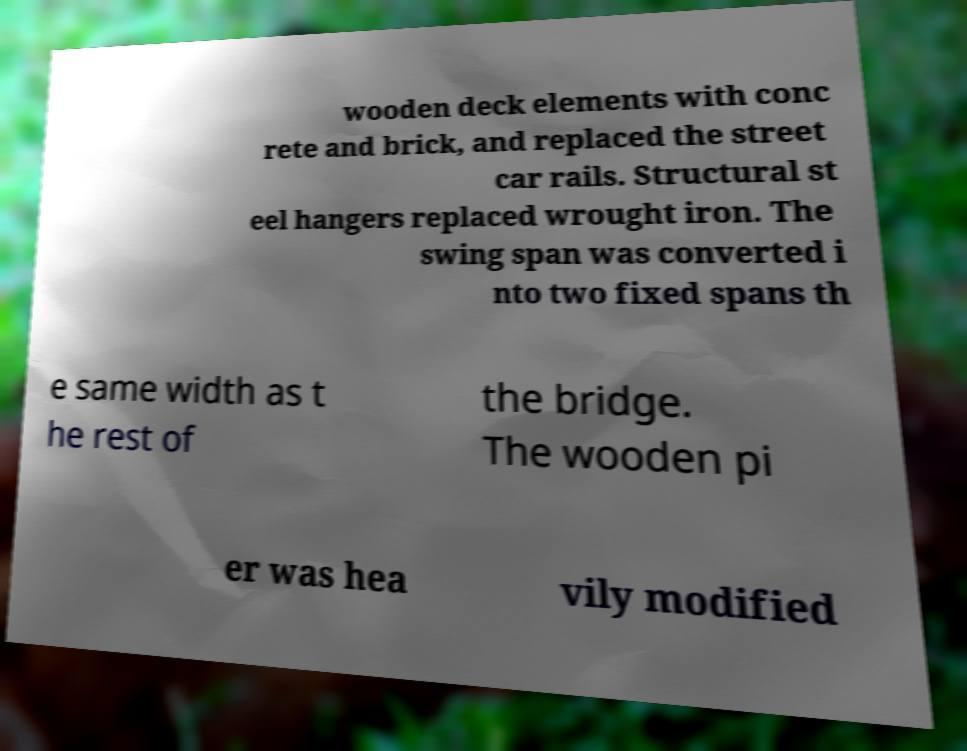There's text embedded in this image that I need extracted. Can you transcribe it verbatim? wooden deck elements with conc rete and brick, and replaced the street car rails. Structural st eel hangers replaced wrought iron. The swing span was converted i nto two fixed spans th e same width as t he rest of the bridge. The wooden pi er was hea vily modified 